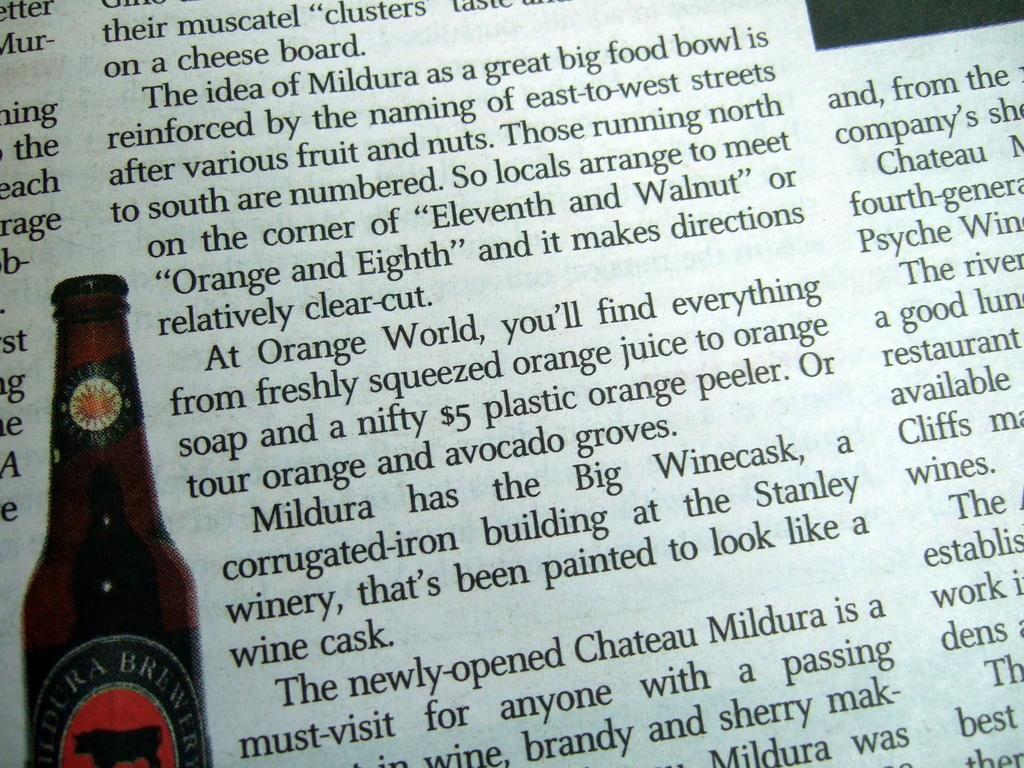What is depicted in the image? There is a picture of a bottle in the image. What else can be seen in the image? There is something written on a paper in the image. What type of knowledge can be gained from the dirt in the image? There is no dirt present in the image, so no knowledge can be gained from it. 